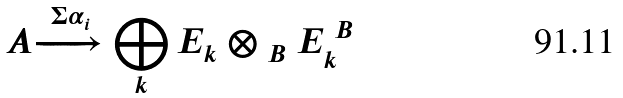Convert formula to latex. <formula><loc_0><loc_0><loc_500><loc_500>\ A \xrightarrow { \Sigma \alpha _ { i } } \bigoplus _ { k } E _ { k } \otimes _ { \ B } E ^ { \ B } _ { k }</formula> 